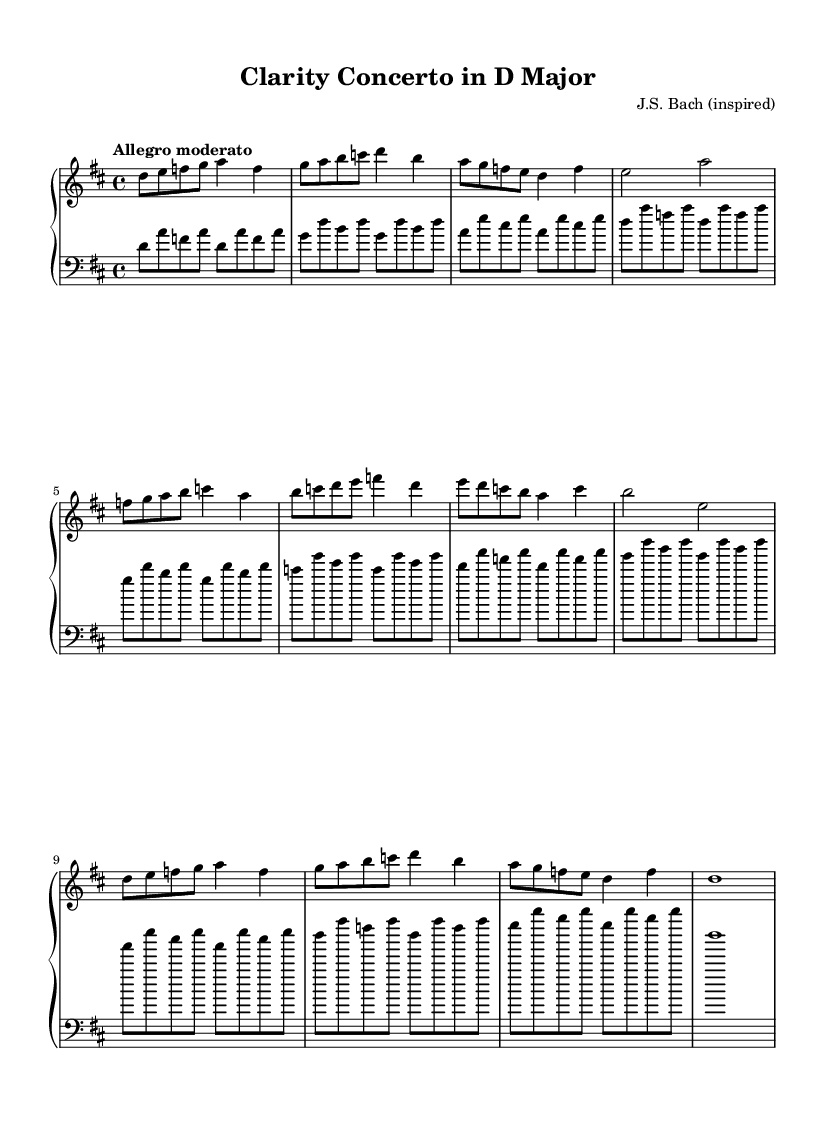What is the key signature of this music? The key signature is identified by the sharp or flat symbols at the beginning of the staff. In this case, the staff shows two sharps, indicating D major.
Answer: D major What is the time signature of this composition? The time signature is shown at the beginning of the staff, which consists of two numbers stacked vertically. The top number is 4 and the bottom number is 4, indicating that there are four beats in each measure and the quarter note gets one beat.
Answer: 4/4 What is the tempo marking of this piece? The tempo marking is indicated by the word or phrase that describes the speed of the music, typically found above the staff. In this case, it says "Allegro moderato," suggesting a moderate, lively tempo.
Answer: Allegro moderato How many sections does this composition have? By examining the structure of the music, it appears to have three main sections: an A section, a B section, and a repeated A’ section.
Answer: Three sections What type of bass pattern is used in the left hand? The left hand plays a repeated pattern that resembles an Alberti bass. This consists of three notes played in a broken chord fashion, often seen in Baroque compositions.
Answer: Alberti bass What is the highest note in the right hand's main theme? To determine the highest note in the right hand, we look through the notes played. The highest note presented in that section is a D, found at specific measures.
Answer: D In what style is this piece composed? The piece exhibits characteristics typical of Baroque music, such as structured form, ornamentation, and counterpoint typically present in compositions from that era, especially influenced by J.S. Bach.
Answer: Baroque 